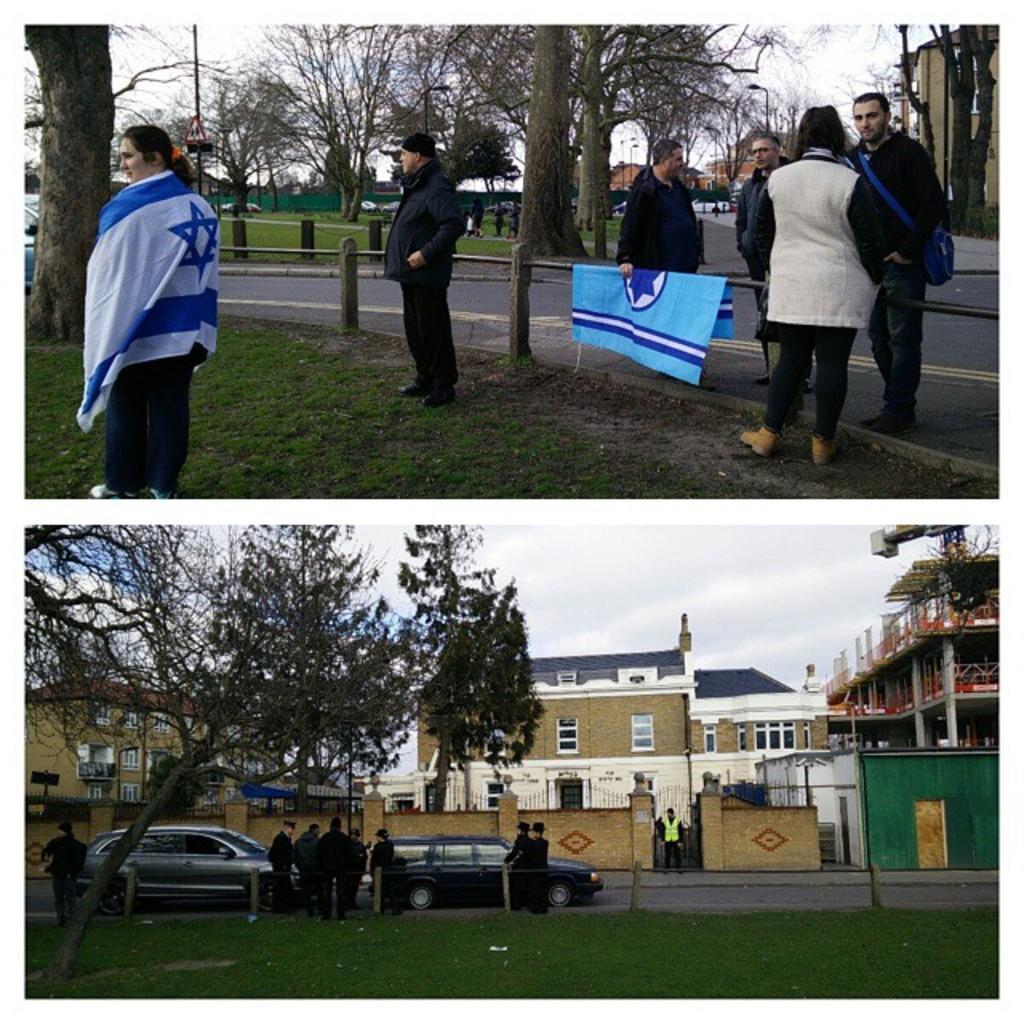Can you describe this image briefly? This picture describes about collage of images, in this we can find few cars, trees, buildings, poles and people, and also we can see a crane and sign boards. 